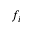Convert formula to latex. <formula><loc_0><loc_0><loc_500><loc_500>f _ { i }</formula> 